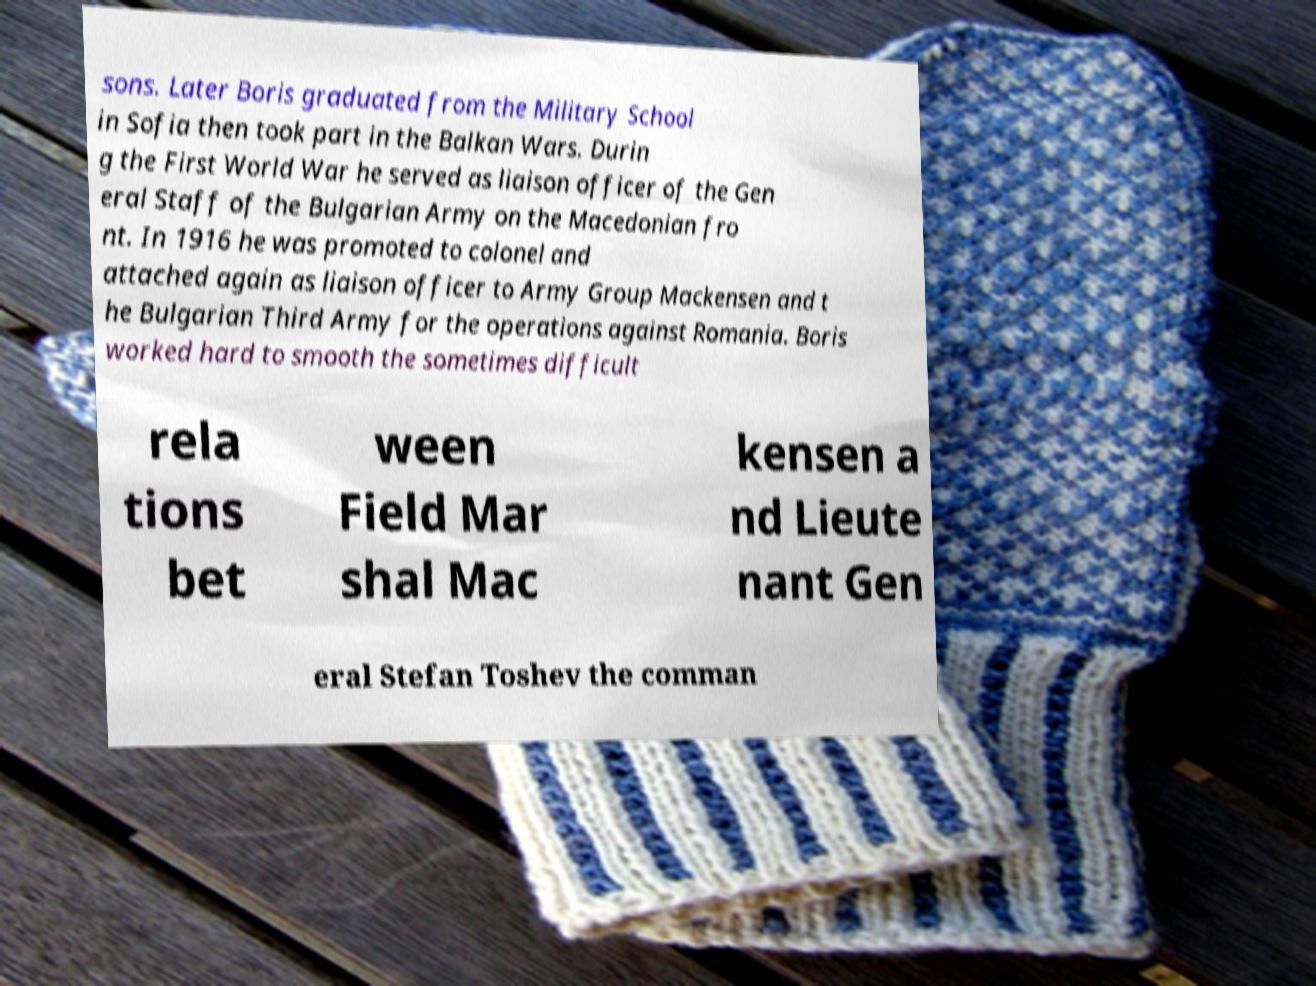Please identify and transcribe the text found in this image. sons. Later Boris graduated from the Military School in Sofia then took part in the Balkan Wars. Durin g the First World War he served as liaison officer of the Gen eral Staff of the Bulgarian Army on the Macedonian fro nt. In 1916 he was promoted to colonel and attached again as liaison officer to Army Group Mackensen and t he Bulgarian Third Army for the operations against Romania. Boris worked hard to smooth the sometimes difficult rela tions bet ween Field Mar shal Mac kensen a nd Lieute nant Gen eral Stefan Toshev the comman 